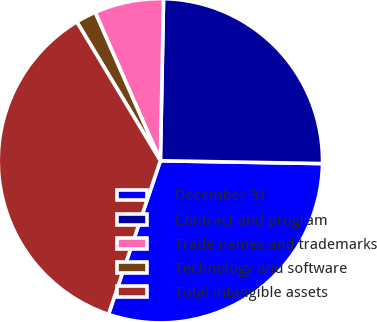Convert chart to OTSL. <chart><loc_0><loc_0><loc_500><loc_500><pie_chart><fcel>December 31<fcel>Contract and program<fcel>Trade names and trademarks<fcel>Technology and software<fcel>Total intangible assets<nl><fcel>29.91%<fcel>24.97%<fcel>6.9%<fcel>2.03%<fcel>36.2%<nl></chart> 